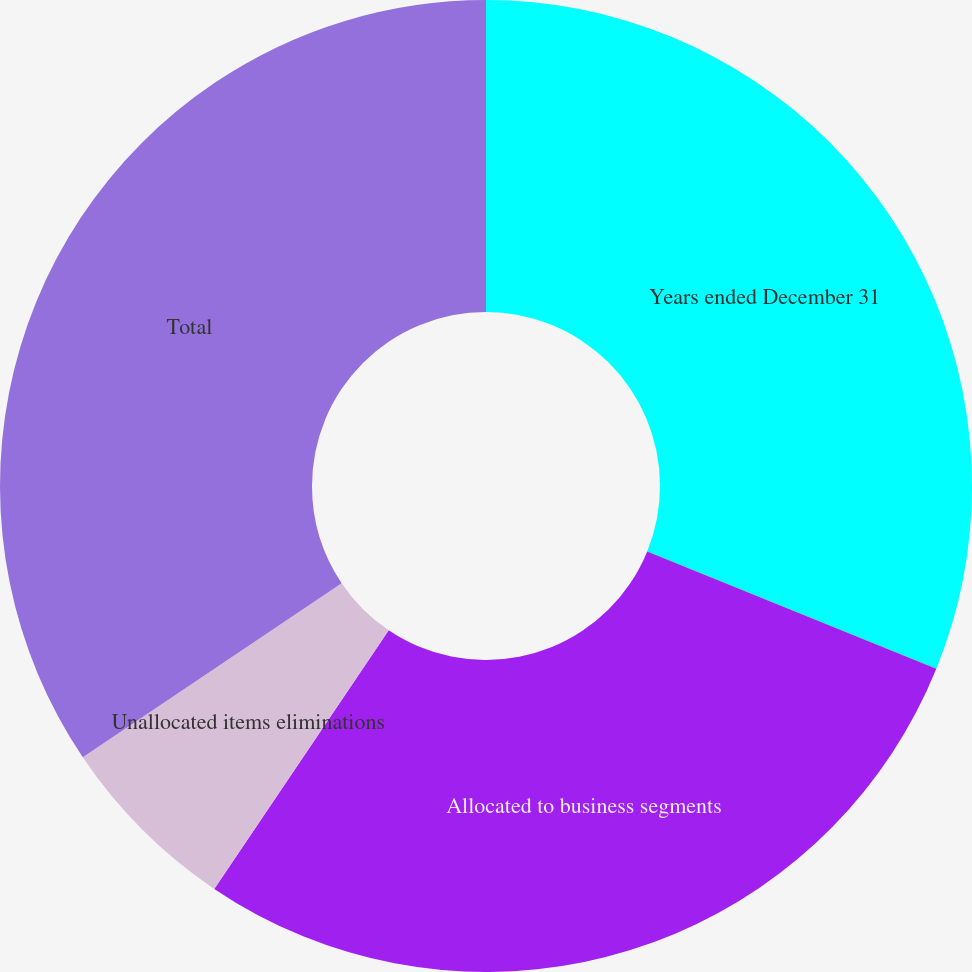Convert chart to OTSL. <chart><loc_0><loc_0><loc_500><loc_500><pie_chart><fcel>Years ended December 31<fcel>Allocated to business segments<fcel>Unallocated items eliminations<fcel>Total<nl><fcel>31.14%<fcel>28.31%<fcel>6.13%<fcel>34.43%<nl></chart> 